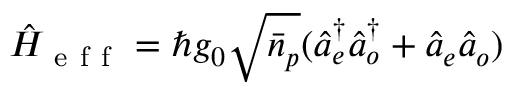<formula> <loc_0><loc_0><loc_500><loc_500>\hat { H } _ { e f f } = \hbar { g } _ { 0 } \sqrt { \bar { n } _ { p } } ( \hat { a } _ { e } ^ { \dagger } \hat { a } _ { o } ^ { \dagger } + \hat { a } _ { e } \hat { a } _ { o } )</formula> 